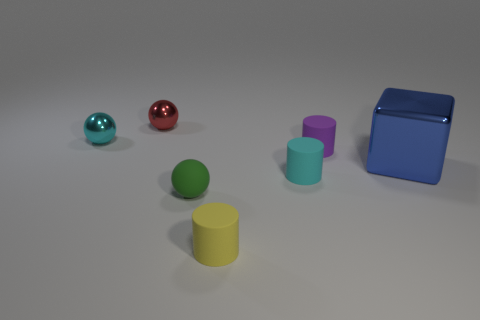Add 1 shiny blocks. How many objects exist? 8 Subtract all cylinders. How many objects are left? 4 Subtract all small cyan balls. Subtract all cyan cylinders. How many objects are left? 5 Add 5 tiny red metallic balls. How many tiny red metallic balls are left? 6 Add 4 small purple cylinders. How many small purple cylinders exist? 5 Subtract 0 green cylinders. How many objects are left? 7 